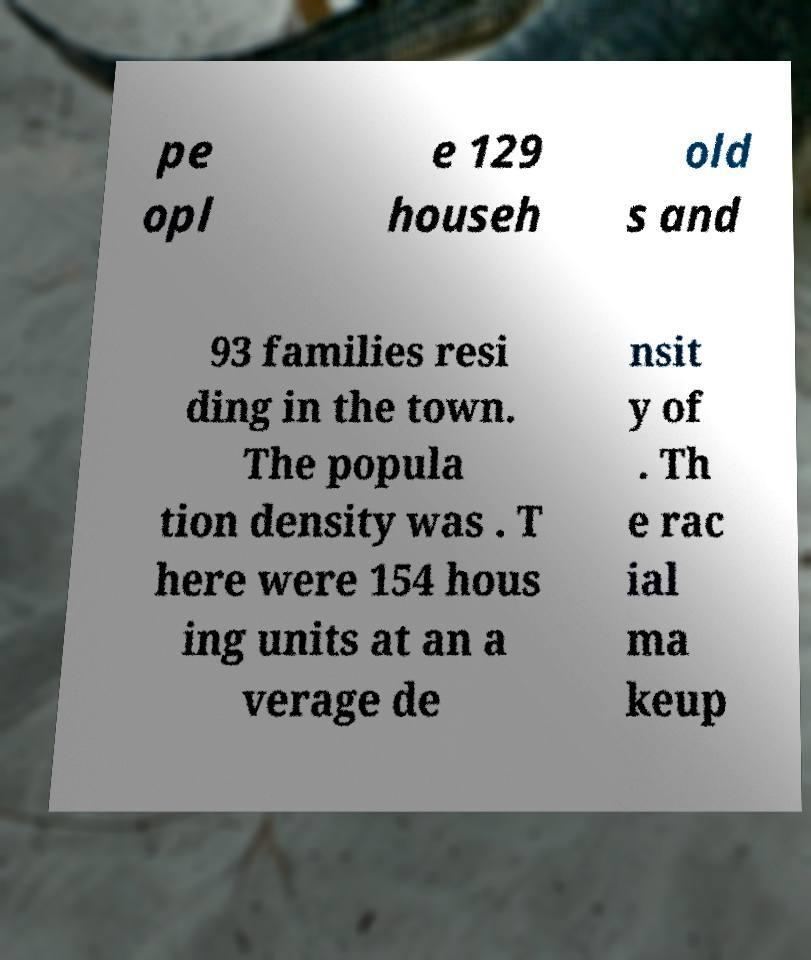Can you read and provide the text displayed in the image?This photo seems to have some interesting text. Can you extract and type it out for me? pe opl e 129 househ old s and 93 families resi ding in the town. The popula tion density was . T here were 154 hous ing units at an a verage de nsit y of . Th e rac ial ma keup 